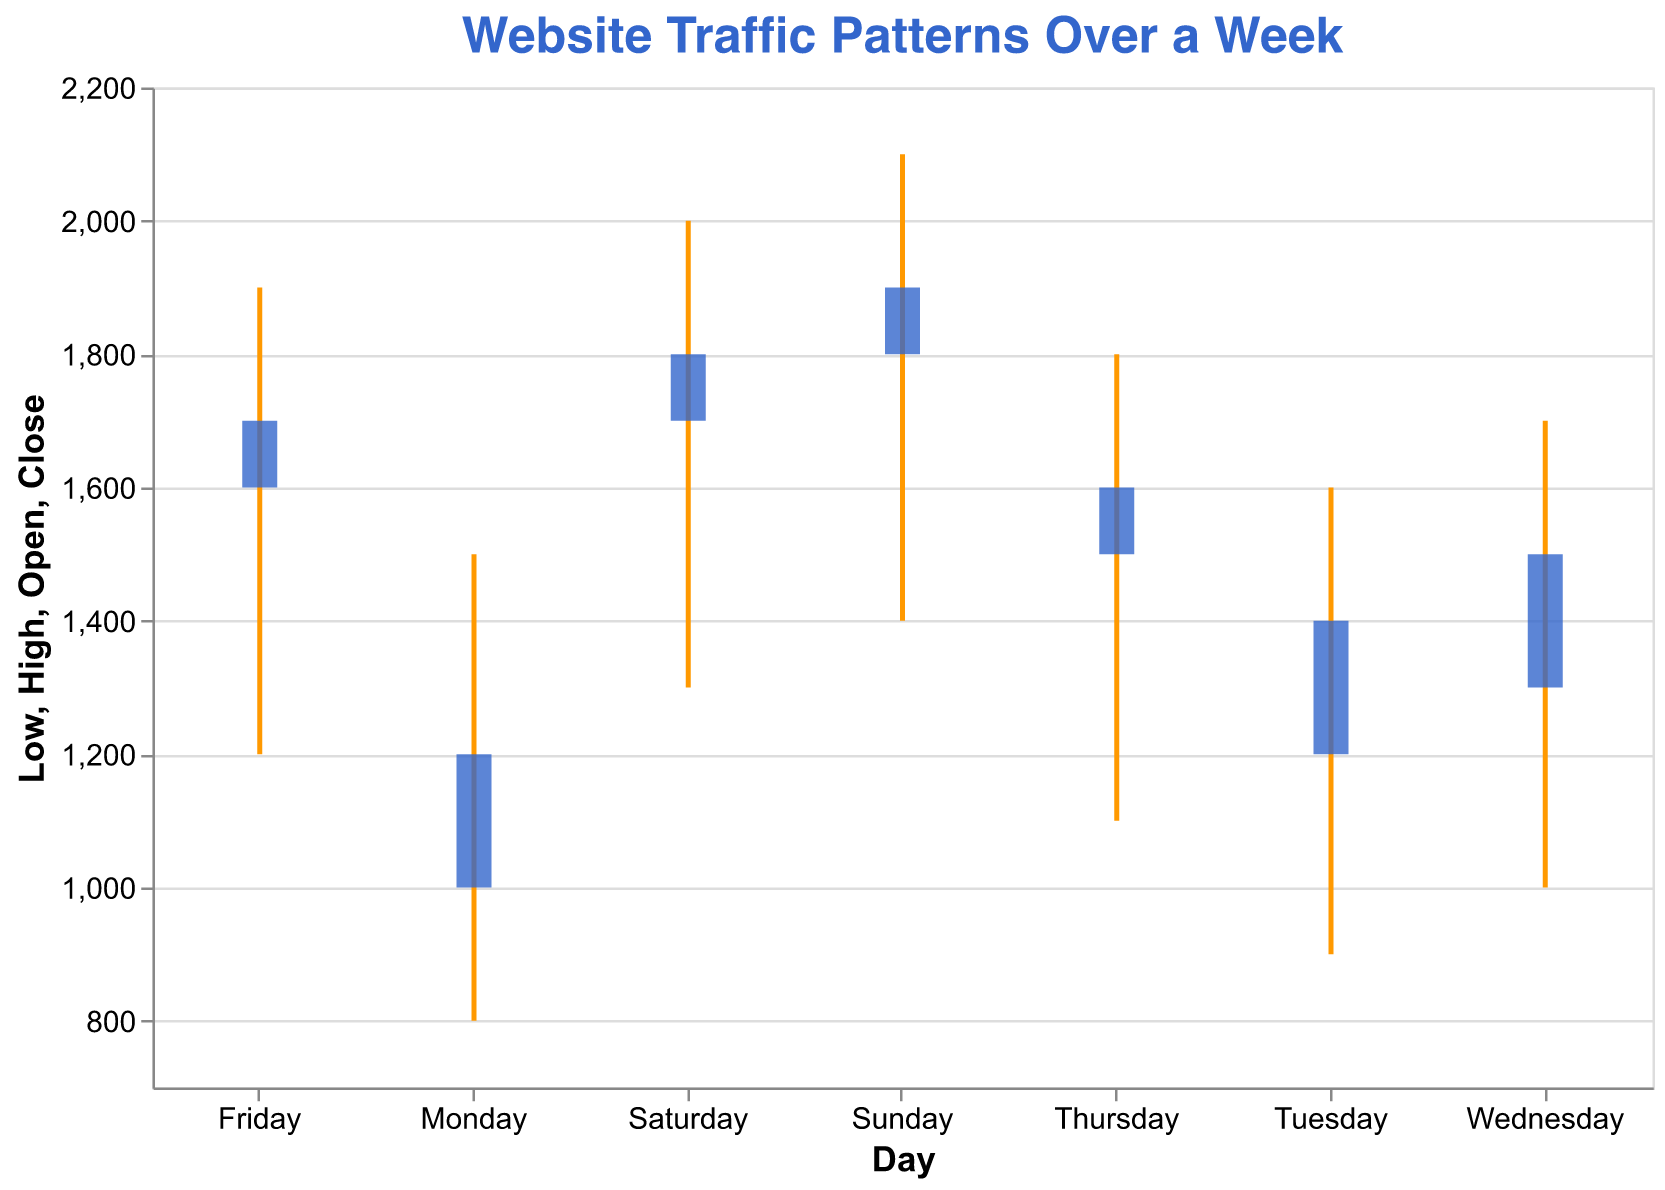What's the title of the figure? The title of the figure is displayed at the top and it reads "Website Traffic Patterns Over a Week".
Answer: Website Traffic Patterns Over a Week Which days have the highest traffic indicated in the "High" value, and what are those values? The highest traffic "High" values occur on Sunday with 2100 and on Saturday with 2000.
Answer: Sunday: 2100, Saturday: 2000 On which day did the website start with the lowest traffic, according to the "Open" value? The lowest "Open" value is on Monday at 1000.
Answer: Monday How many days showed an increase in traffic from the "Open" to the "Close" value? By checking the "Open" and "Close" values for each day, we see that traffic increases from "Open" to "Close" on all days because the "Close" value is always higher than the "Open" value.
Answer: 7 What is the average "High" value of website traffic over the week? To find the average "High" value, sum all "High" values: 1500 + 1600 + 1700 + 1800 + 1900 + 2000 + 2100 = 12600. Then divide by the number of days (7). 12600 / 7 = 1800.
Answer: 1800 Which day has the largest traffic range, and what is the difference between the "High" and "Low" values on that day? The largest range can be found by subtracting "Low" from "High" for each day. Sunday has 2100 - 1400 = 700, which is the highest value.
Answer: Sunday: 700 Which day had the earliest peak start hour, and what time was it? The peak start hour is listed in the data. The earliest peak start hour is on Monday at 10:00.
Answer: Monday: 10:00 Compare the "Low" value between Wednesday and Friday. Which day had a lower value and by how much? Wednesday's "Low" is 1000, and Friday's "Low" is 1200. 1200 - 1000 = 200, so Wednesday had a lower value by 200.
Answer: Wednesday by 200 What’s the overall trend of the "Close" values from Monday to Sunday, and what does this indicate? Observing the "Close" values from Monday (1200) to Sunday (1900), the trend shows a steady increase over the week.
Answer: Increasing trend Considering the data given, what can you infer about the relationship between peak hour traffic and off-peak hour traffic across the week? Peak hour traffic is generally higher than off-peak hour traffic, as indicated by the "High" values typically being more than the "Low" values. Since peak hours fall later in the day and off-peak hours are early morning, this indicates higher website activity during later hours.
Answer: Peak hours have higher traffic 